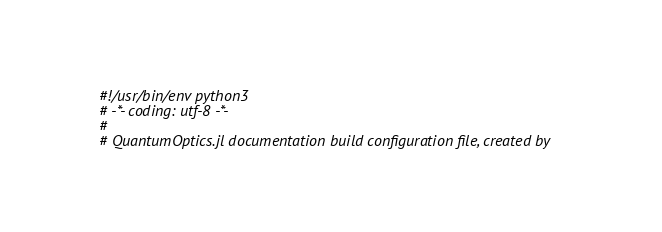Convert code to text. <code><loc_0><loc_0><loc_500><loc_500><_Python_>#!/usr/bin/env python3
# -*- coding: utf-8 -*-
#
# QuantumOptics.jl documentation build configuration file, created by</code> 